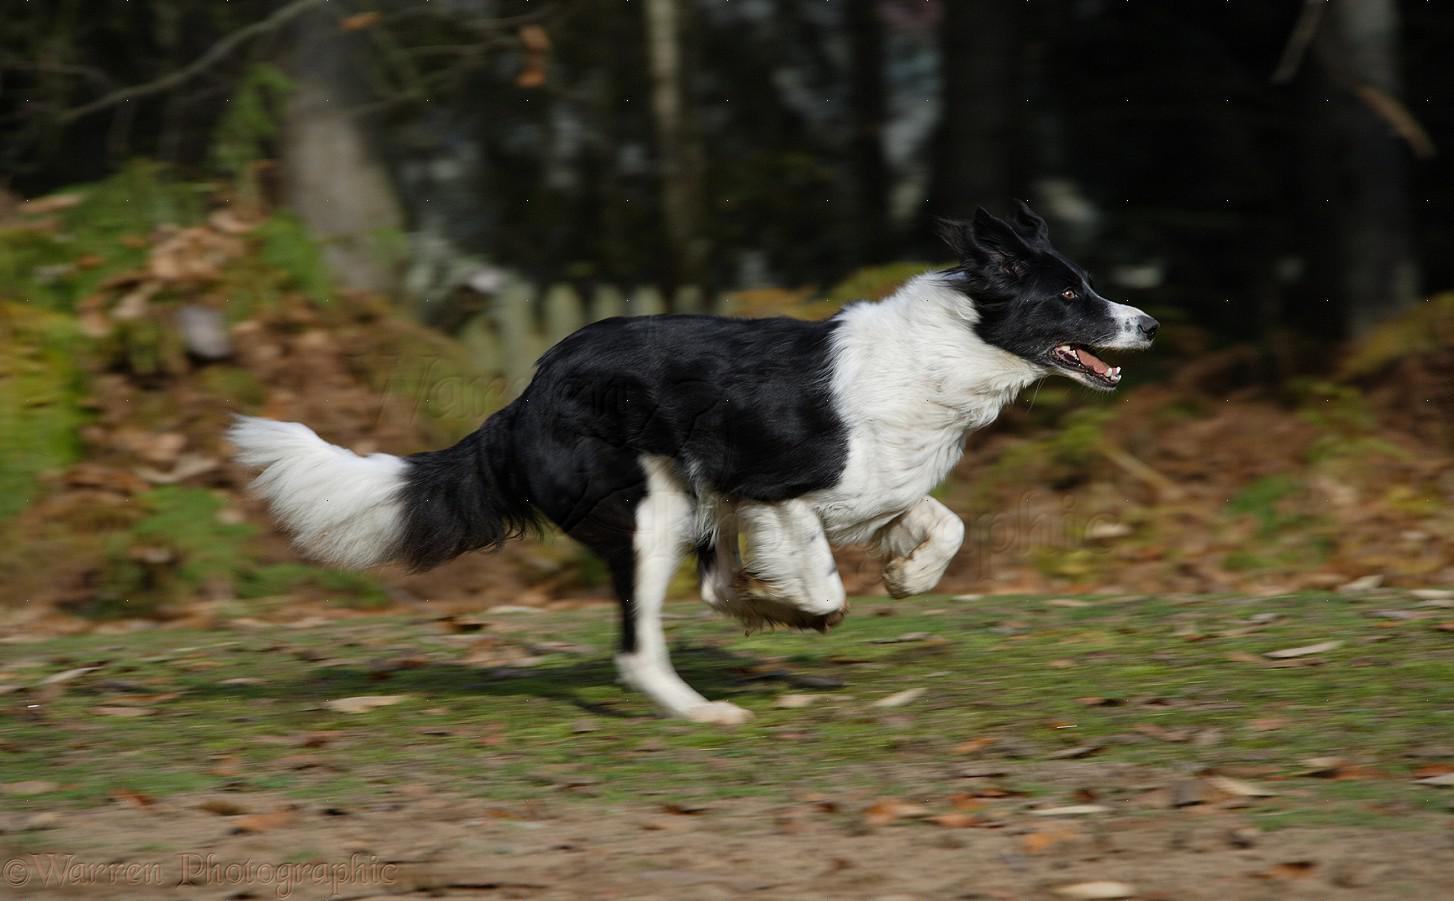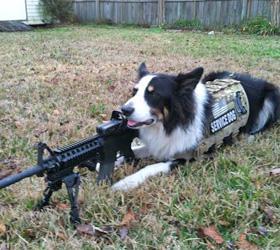The first image is the image on the left, the second image is the image on the right. Assess this claim about the two images: "There is a diagonal, rod-like dark object near at least one reclining dog.". Correct or not? Answer yes or no. Yes. 